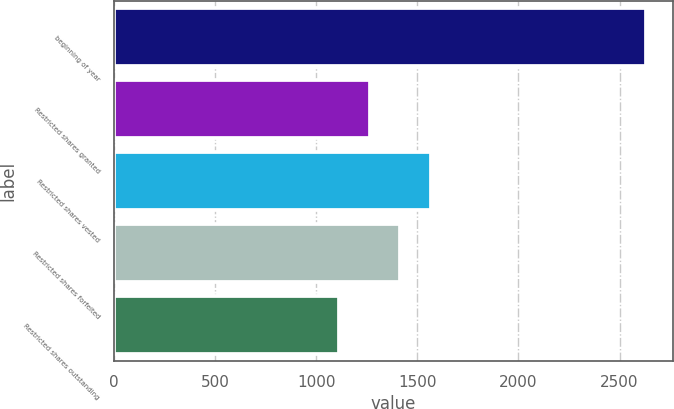Convert chart to OTSL. <chart><loc_0><loc_0><loc_500><loc_500><bar_chart><fcel>beginning of year<fcel>Restricted shares granted<fcel>Restricted shares vested<fcel>Restricted shares forfeited<fcel>Restricted shares outstanding<nl><fcel>2632<fcel>1264<fcel>1568<fcel>1416<fcel>1112<nl></chart> 